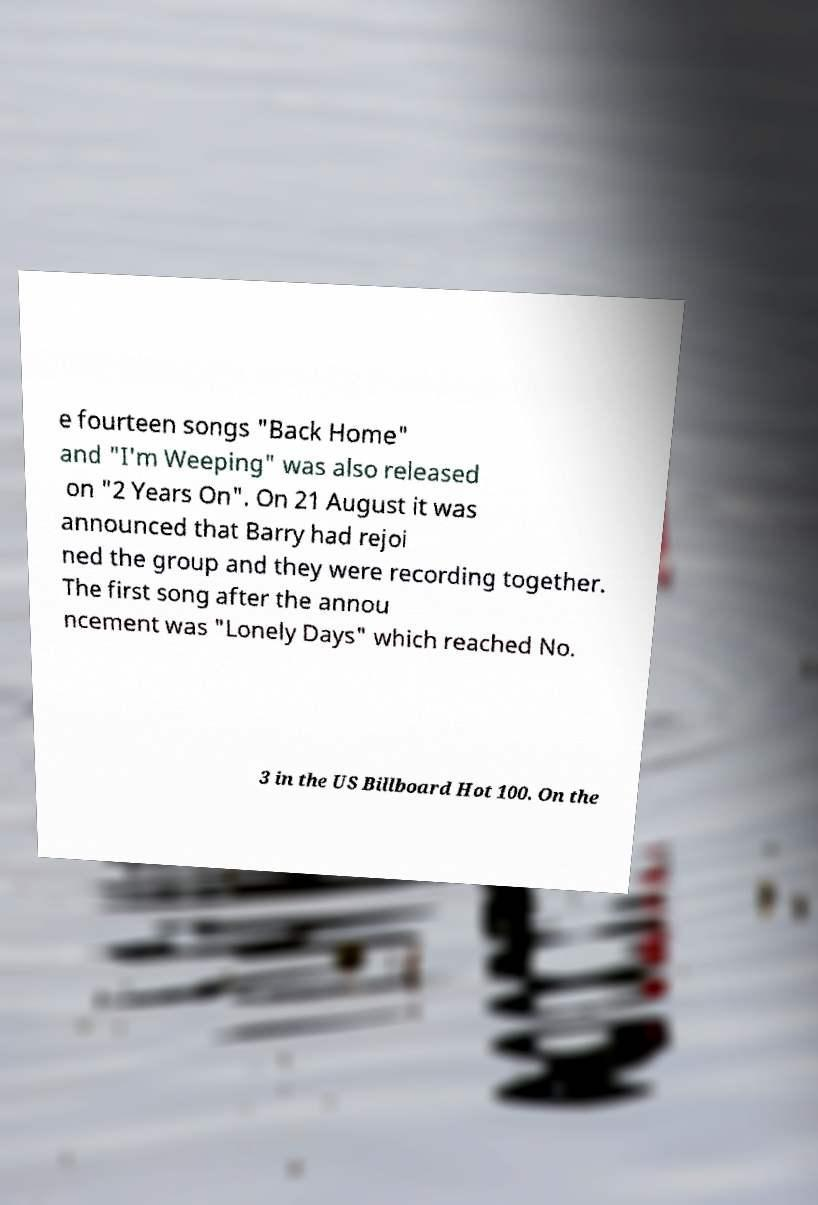Could you assist in decoding the text presented in this image and type it out clearly? e fourteen songs "Back Home" and "I'm Weeping" was also released on "2 Years On". On 21 August it was announced that Barry had rejoi ned the group and they were recording together. The first song after the annou ncement was "Lonely Days" which reached No. 3 in the US Billboard Hot 100. On the 